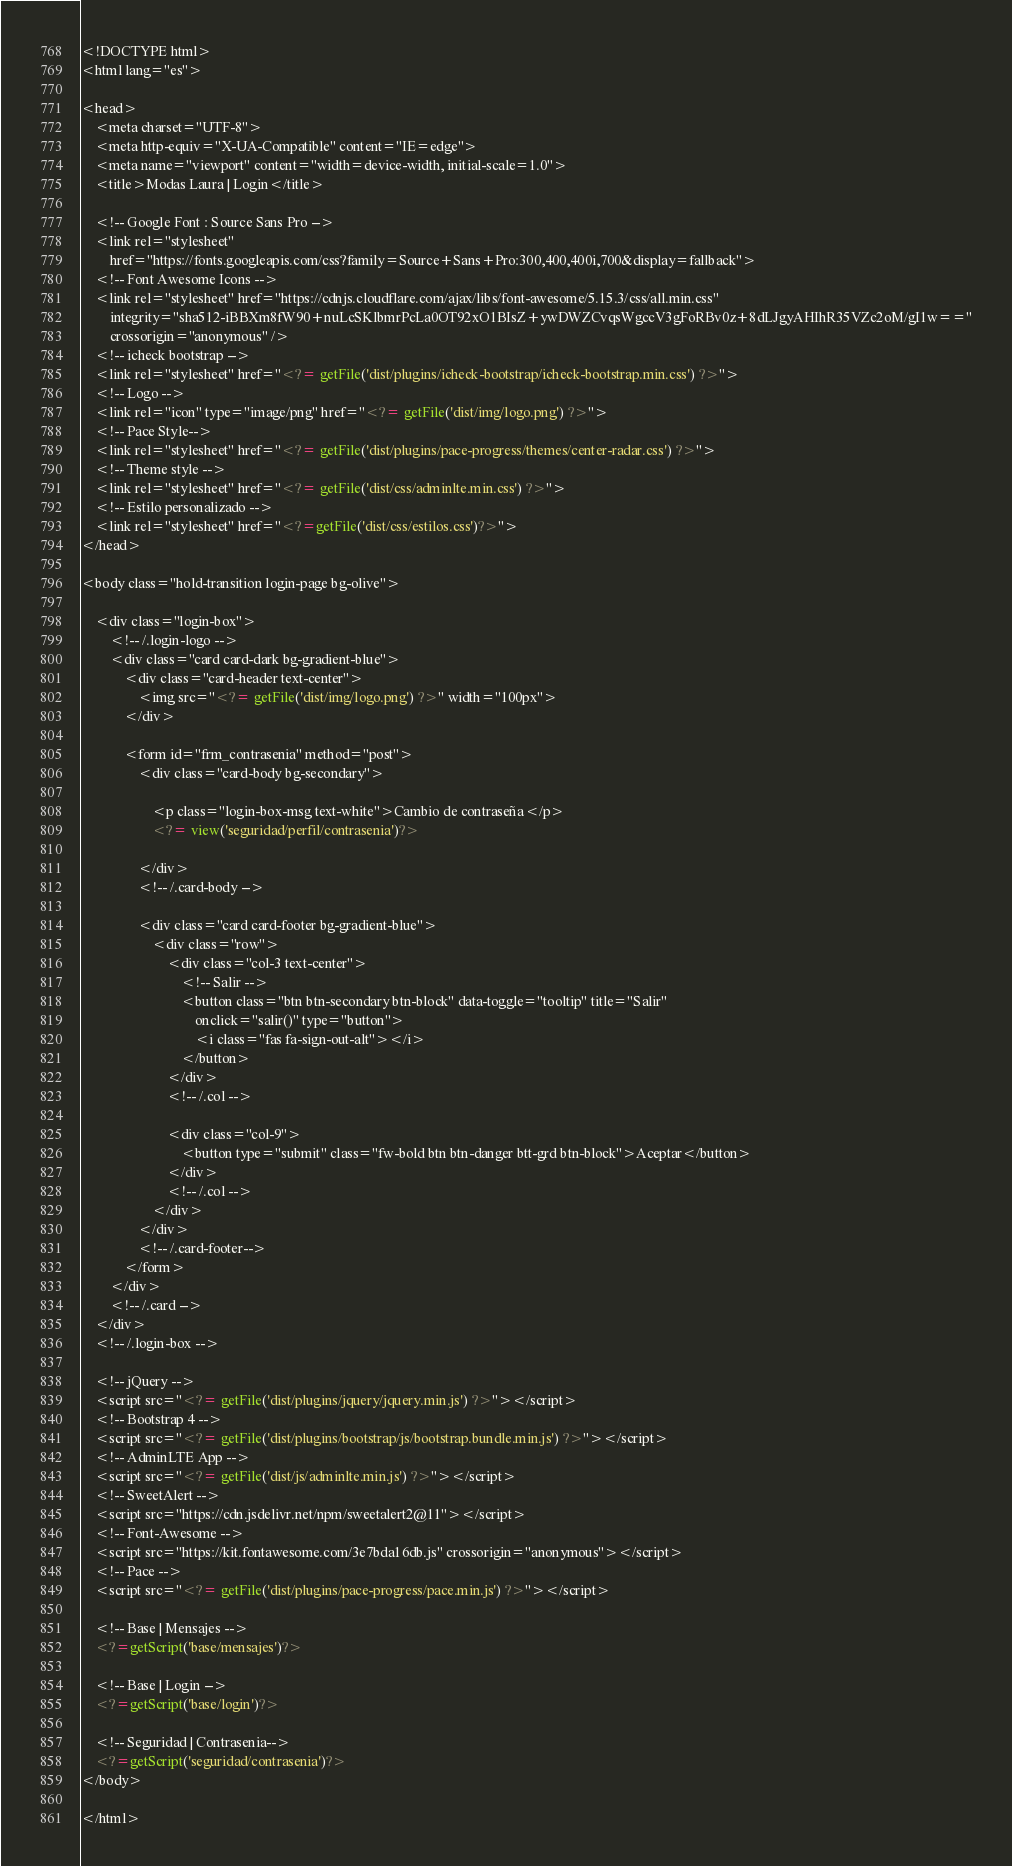Convert code to text. <code><loc_0><loc_0><loc_500><loc_500><_PHP_><!DOCTYPE html>
<html lang="es">

<head>
    <meta charset="UTF-8">
    <meta http-equiv="X-UA-Compatible" content="IE=edge">
    <meta name="viewport" content="width=device-width, initial-scale=1.0">
    <title>Modas Laura | Login</title>

    <!-- Google Font : Source Sans Pro -->
    <link rel="stylesheet"
        href="https://fonts.googleapis.com/css?family=Source+Sans+Pro:300,400,400i,700&display=fallback">
    <!-- Font Awesome Icons -->
    <link rel="stylesheet" href="https://cdnjs.cloudflare.com/ajax/libs/font-awesome/5.15.3/css/all.min.css"
        integrity="sha512-iBBXm8fW90+nuLcSKlbmrPcLa0OT92xO1BIsZ+ywDWZCvqsWgccV3gFoRBv0z+8dLJgyAHIhR35VZc2oM/gI1w=="
        crossorigin="anonymous" />
    <!-- icheck bootstrap -->
    <link rel="stylesheet" href="<?= getFile('dist/plugins/icheck-bootstrap/icheck-bootstrap.min.css') ?>">
    <!-- Logo -->
    <link rel="icon" type="image/png" href="<?= getFile('dist/img/logo.png') ?>">
    <!-- Pace Style-->
    <link rel="stylesheet" href="<?= getFile('dist/plugins/pace-progress/themes/center-radar.css') ?>">
    <!-- Theme style -->
    <link rel="stylesheet" href="<?= getFile('dist/css/adminlte.min.css') ?>">
    <!-- Estilo personalizado -->
    <link rel="stylesheet" href="<?=getFile('dist/css/estilos.css')?>">
</head>

<body class="hold-transition login-page bg-olive">

    <div class="login-box">
        <!-- /.login-logo -->
        <div class="card card-dark bg-gradient-blue">
            <div class="card-header text-center">
                <img src="<?= getFile('dist/img/logo.png') ?>" width="100px">
            </div>

            <form id="frm_contrasenia" method="post">
                <div class="card-body bg-secondary">

                    <p class="login-box-msg text-white">Cambio de contraseña</p>
                    <?= view('seguridad/perfil/contrasenia')?>

                </div>
                <!-- /.card-body -->

                <div class="card card-footer bg-gradient-blue">
                    <div class="row">
                        <div class="col-3 text-center">
                            <!-- Salir -->
                            <button class="btn btn-secondary btn-block" data-toggle="tooltip" title="Salir"
                                onclick="salir()" type="button">
                                <i class="fas fa-sign-out-alt"></i>
                            </button>
                        </div>
                        <!-- /.col -->

                        <div class="col-9">
                            <button type="submit" class="fw-bold btn btn-danger btt-grd btn-block">Aceptar</button>
                        </div>
                        <!-- /.col -->
                    </div>
                </div>
                <!-- /.card-footer-->
            </form>
        </div>
        <!-- /.card -->
    </div>
    <!-- /.login-box -->

    <!-- jQuery -->
    <script src="<?= getFile('dist/plugins/jquery/jquery.min.js') ?>"></script>
    <!-- Bootstrap 4 -->
    <script src="<?= getFile('dist/plugins/bootstrap/js/bootstrap.bundle.min.js') ?>"></script>
    <!-- AdminLTE App -->
    <script src="<?= getFile('dist/js/adminlte.min.js') ?>"></script>
    <!-- SweetAlert -->
    <script src="https://cdn.jsdelivr.net/npm/sweetalert2@11"></script>
    <!-- Font-Awesome -->
    <script src="https://kit.fontawesome.com/3e7bda16db.js" crossorigin="anonymous"></script>
    <!-- Pace -->
    <script src="<?= getFile('dist/plugins/pace-progress/pace.min.js') ?>"></script>

    <!-- Base | Mensajes -->
    <?=getScript('base/mensajes')?>

    <!-- Base | Login -->
    <?=getScript('base/login')?>

    <!-- Seguridad | Contrasenia-->
    <?=getScript('seguridad/contrasenia')?>
</body>

</html></code> 